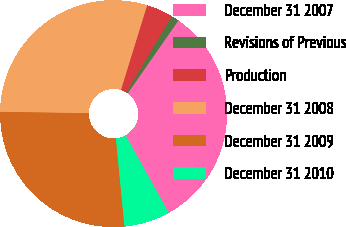Convert chart. <chart><loc_0><loc_0><loc_500><loc_500><pie_chart><fcel>December 31 2007<fcel>Revisions of Previous<fcel>Production<fcel>December 31 2008<fcel>December 31 2009<fcel>December 31 2010<nl><fcel>32.24%<fcel>1.09%<fcel>3.81%<fcel>29.52%<fcel>26.8%<fcel>6.54%<nl></chart> 